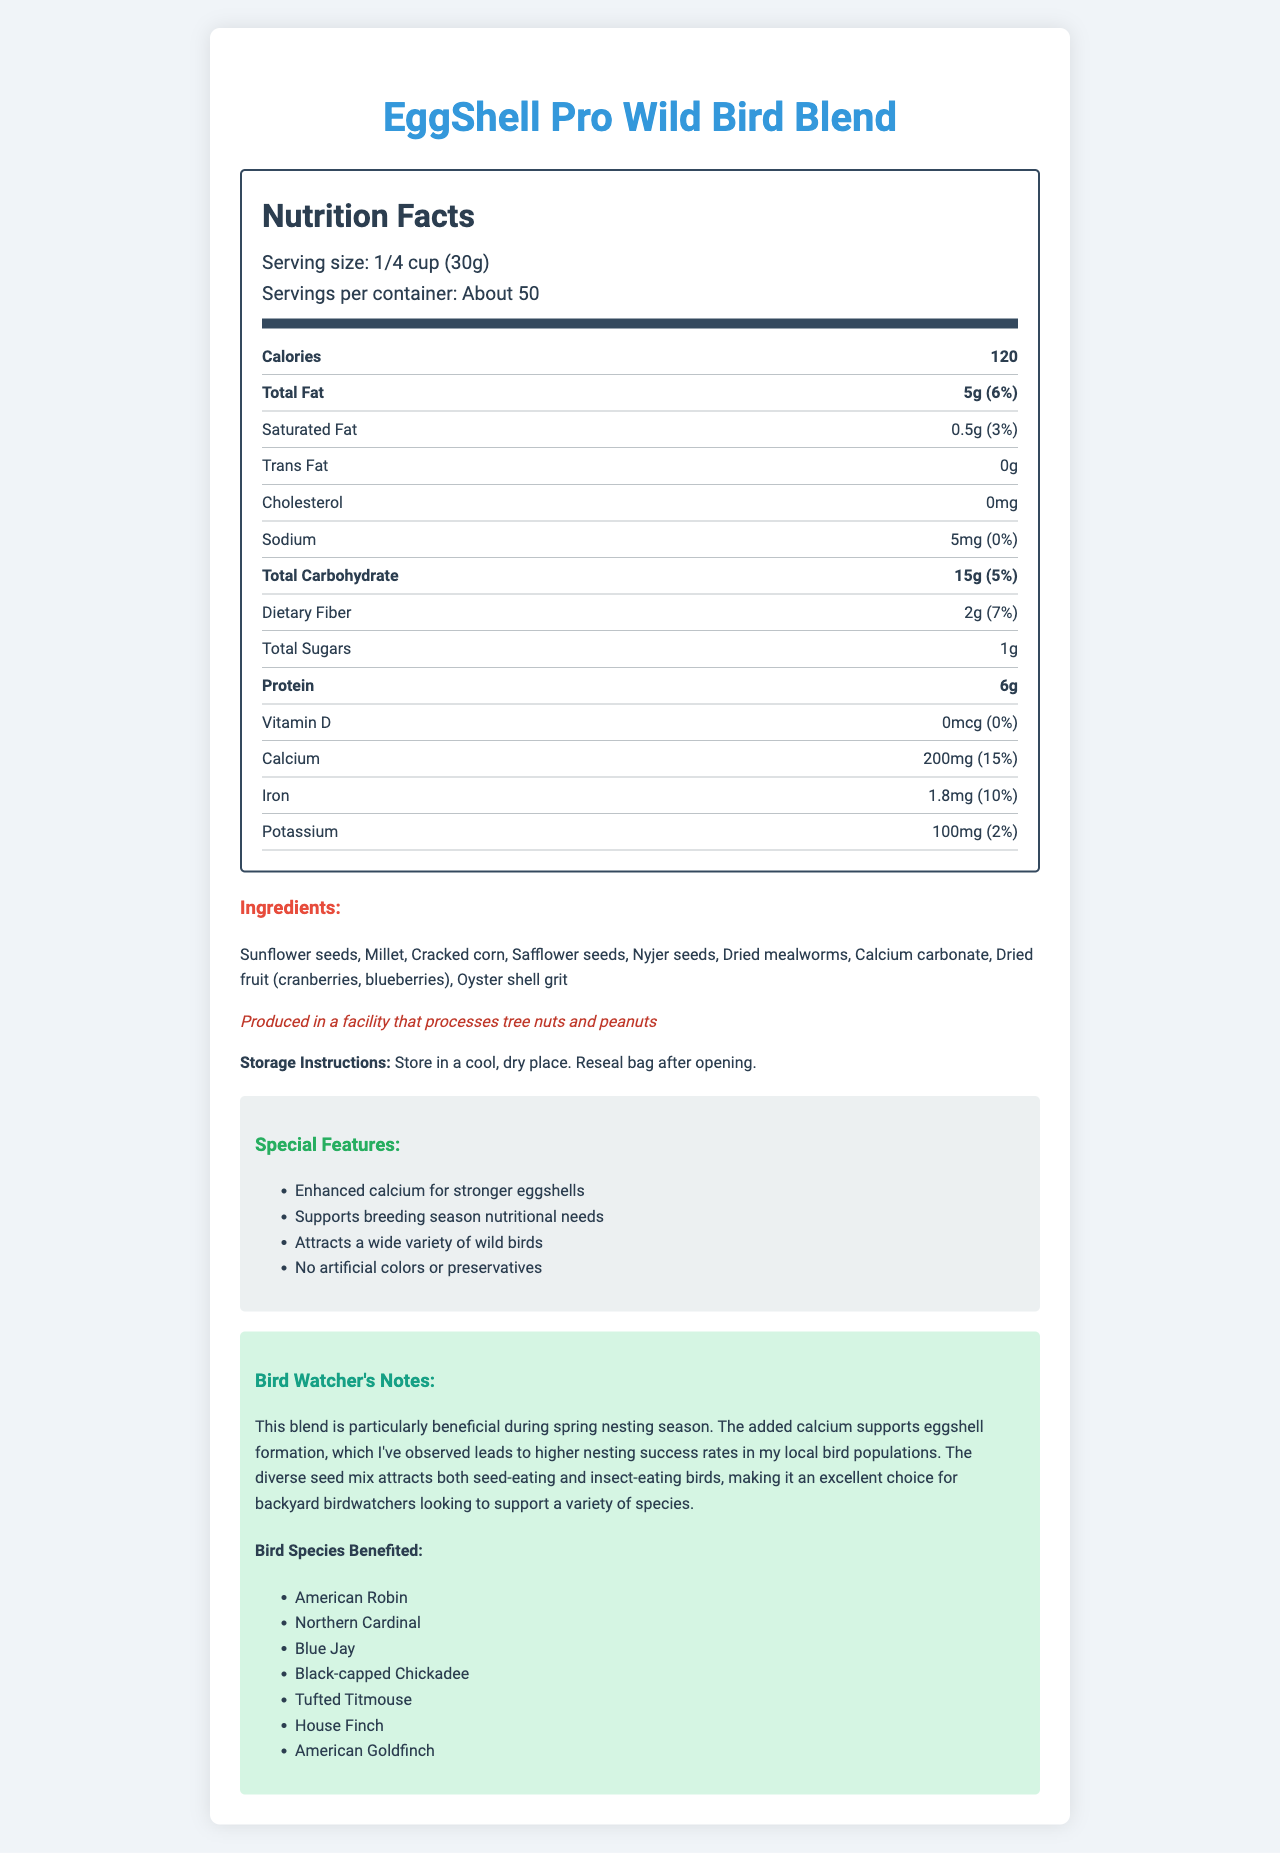what is the serving size of EggShell Pro Wild Bird Blend? The serving size is explicitly mentioned in the document as "1/4 cup (30g)".
Answer: 1/4 cup (30g) how many calories are there per serving? The document clearly states that each serving contains 120 calories.
Answer: 120 name three ingredients in the EggShell Pro Wild Bird Blend. The ingredients list includes these three among others.
Answer: Sunflower seeds, Millet, Cracked corn what special feature supports breeding season nutritional needs? The document lists "Supports breeding season nutritional needs" as one of the special features, specifically mentioning enhanced calcium for stronger eggshells.
Answer: Enhanced calcium for stronger eggshells what is the storage instruction for this bird food blend? The storage instructions are clearly provided in the document.
Answer: Store in a cool, dry place. Reseal bag after opening. which bird species are mentioned as beneficiaries? A. American Robin B. Blue Jay C. House Finch D. Northern Cardinal E. All of the above The document lists multiple bird species, including American Robin, Blue Jay, House Finch, and Northern Cardinal as beneficiaries.
Answer: E. All of the above how much protein is in this bird food blend per serving? A. 5g B. 6g C. 7g The document specifies that each serving contains 6g of protein.
Answer: B does this product include trans fat? The document states that the trans fat content is 0g.
Answer: No is the EggShell Pro Wild Bird Blend produced in a peanut-free facility? The document mentions that the product is produced in a facility that processes tree nuts and peanuts.
Answer: No summarize the main features and benefits of the EggShell Pro Wild Bird Blend. The document focuses on the special features of the blend, such as enhanced calcium for stronger eggshells, and emphasizes its benefits like supporting breeding season nutritional needs and attracting a wide variety of birds.
Answer: The EggShell Pro Wild Bird Blend is a specially crafted wild bird food with added calcium for eggshell formation. It contains a variety of seeds and dried mealworms, and supports breeding season nutritional needs. Additionally, it attracts a variety of wild birds and contains no artificial colors or preservatives. how many sugars does this bird blend contain? The exact amount of sugars isn't specified, only the total sugars amount per serving, which is 1g.
Answer: I don't know 